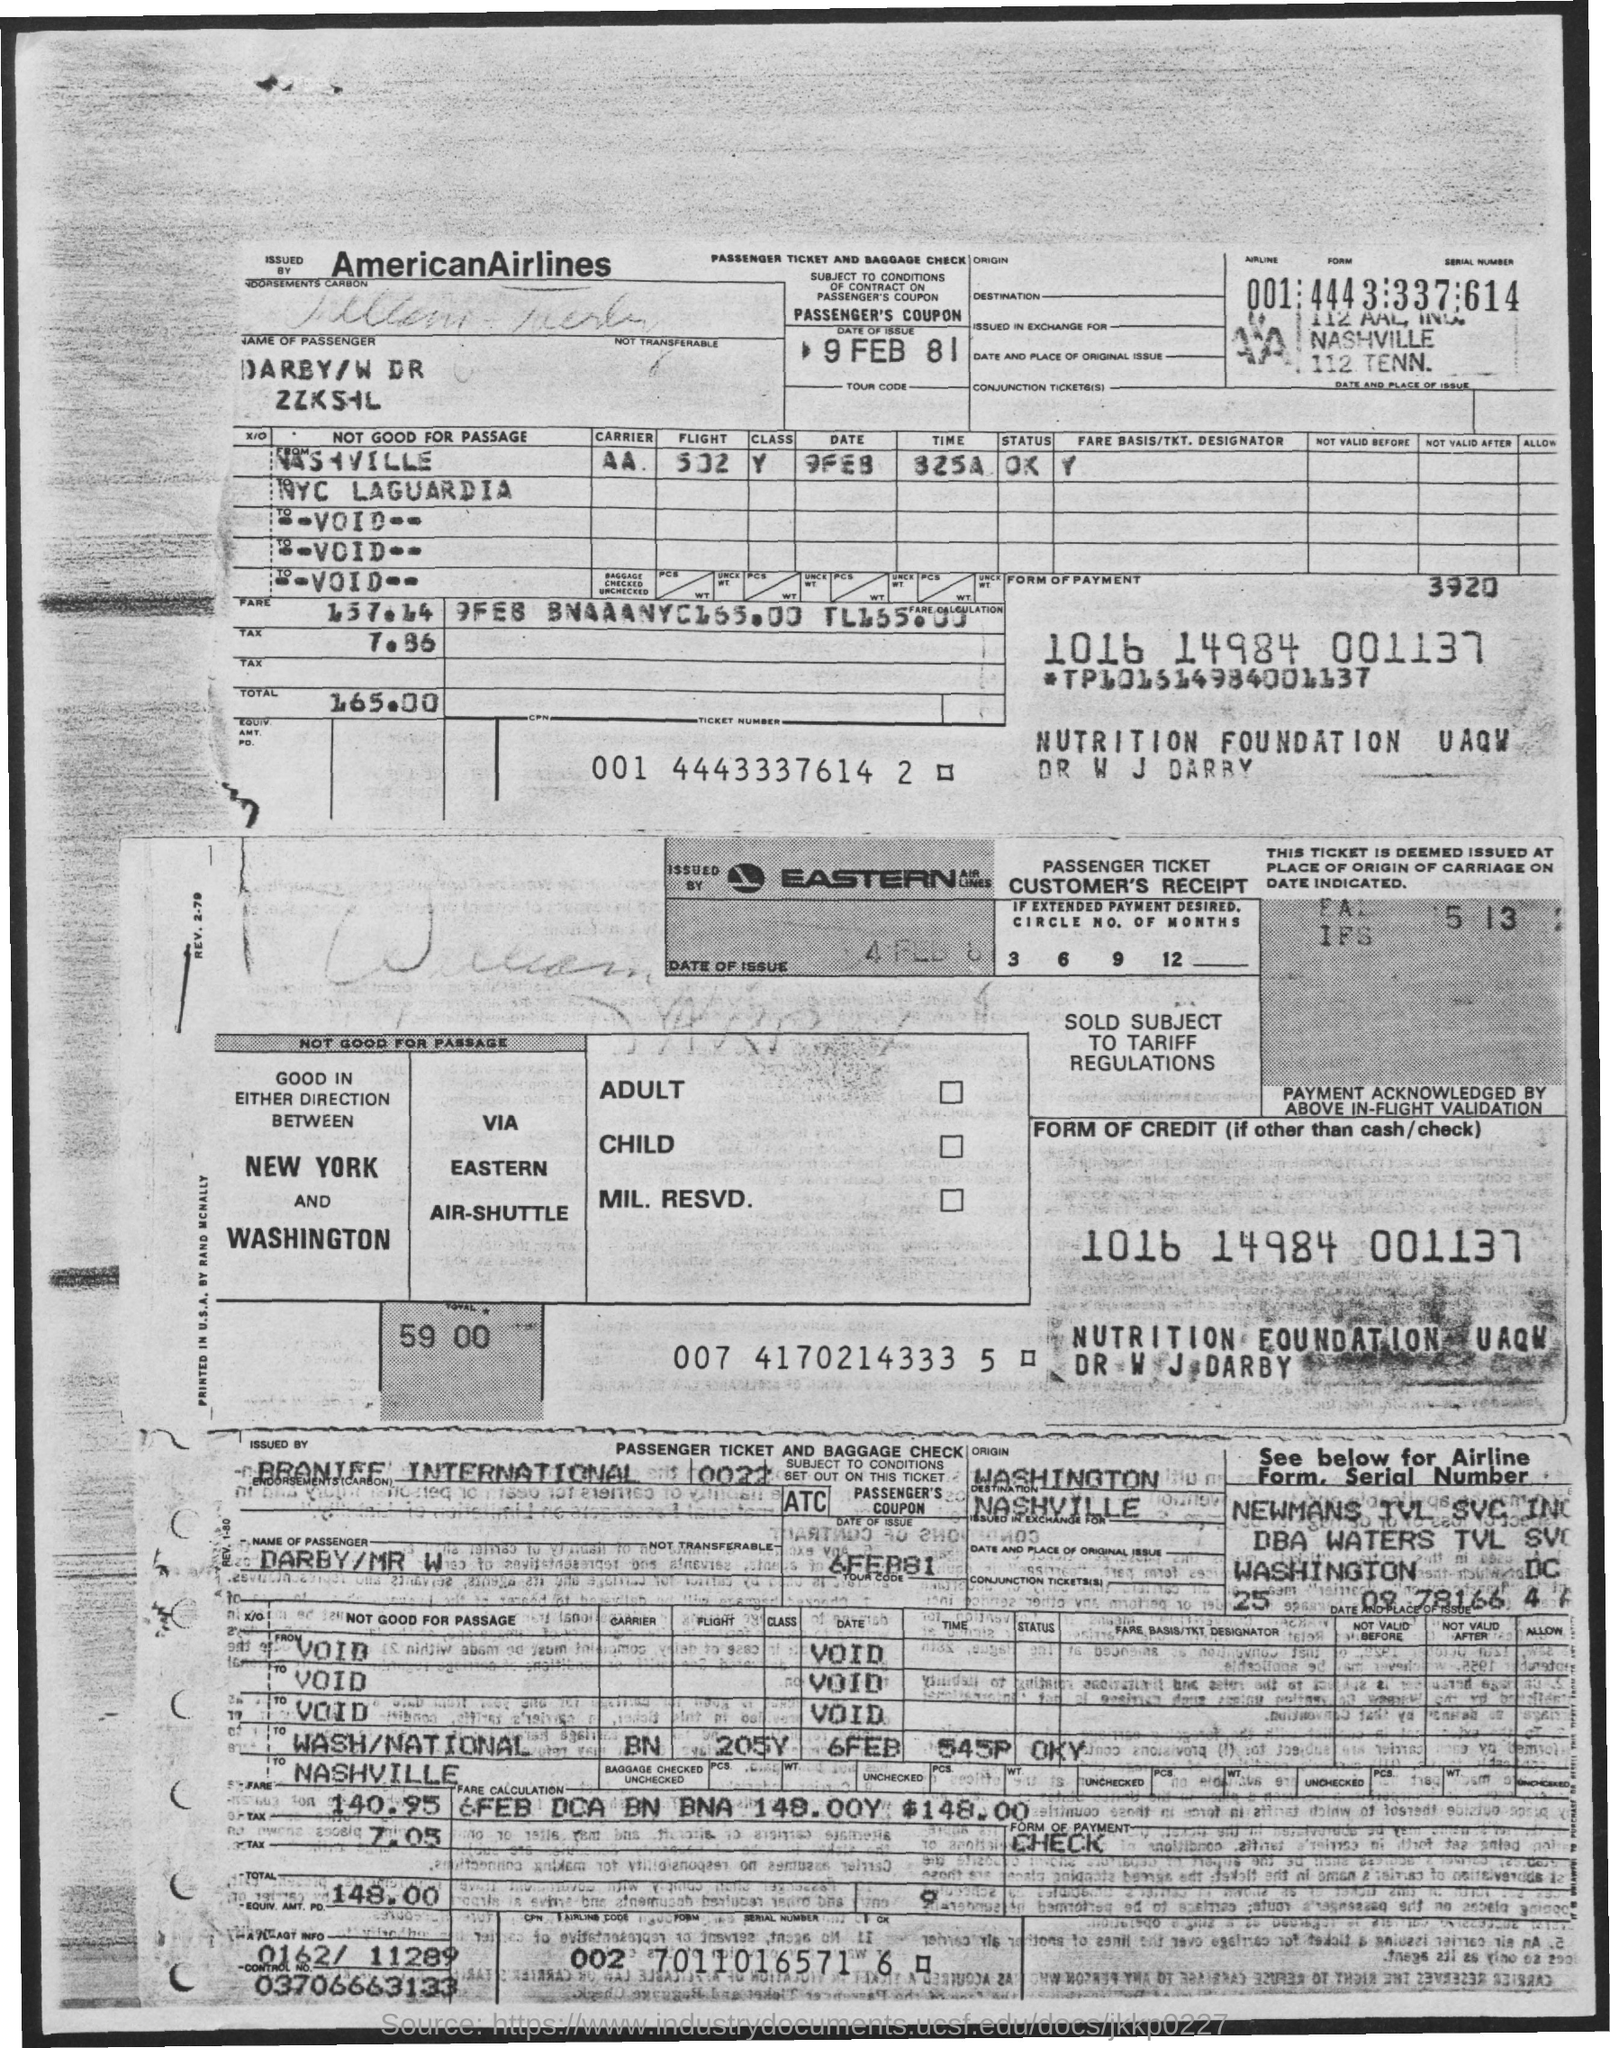Draw attention to some important aspects in this diagram. The date of issue for the passenger ticket of American Airlines is February 9, 1981. The control number is 03706663133... On February 6th, 1981, Eastern Airlines issued a passenger ticket. American Airlines is the airline code for American Airlines. 